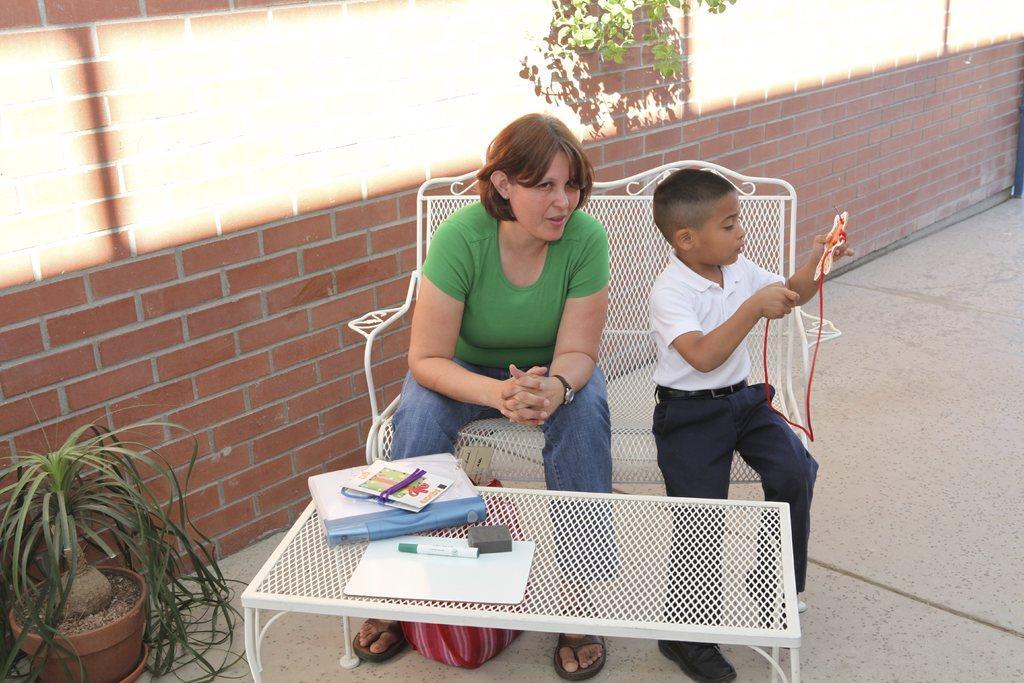How would you summarize this image in a sentence or two? Left side of an image there is a brick wall in the middle a woman is sitting on the chair and a boy is sitting and playing with a toy and on the table there are books. Here it's a plant. 